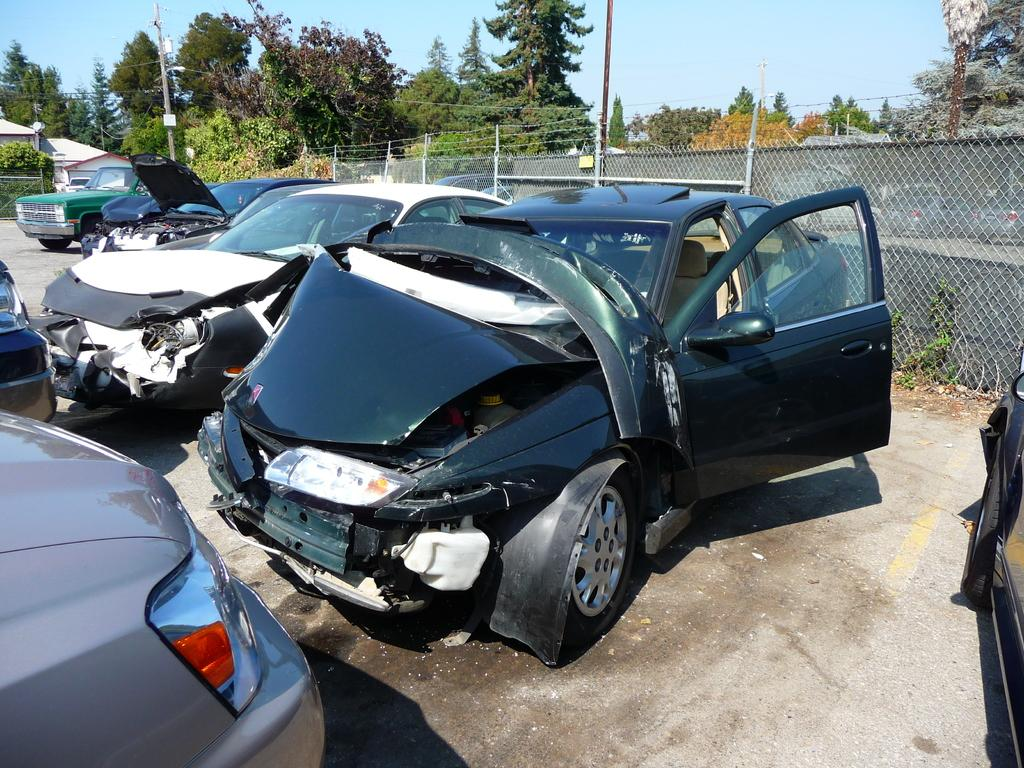What types of objects are present in the image? There are vehicles in the image. Can you describe one of the vehicles? One of the vehicles is black. What can be seen in the background of the image? There are trees in the background of the image. What color are the trees? The trees are green. What color is the sky in the image? The sky is blue. What type of crime is being committed in the image? There is no indication of any crime being committed in the image. The image features vehicles, trees, and a blue sky. 